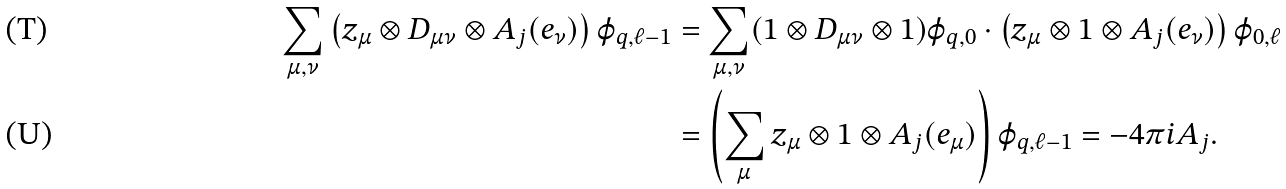<formula> <loc_0><loc_0><loc_500><loc_500>\sum _ { \mu , \nu } \left ( z _ { \mu } \otimes D _ { \mu \nu } \otimes A _ { j } ( e _ { \nu } ) \right ) \varphi _ { q , \ell - 1 } & = \sum _ { \mu , \nu } ( 1 \otimes D _ { \mu \nu } \otimes 1 ) \varphi _ { q , 0 } \cdot \left ( z _ { \mu } \otimes 1 \otimes A _ { j } ( e _ { \nu } ) \right ) \varphi _ { 0 , \ell } \\ & = \left ( \sum _ { \mu } z _ { \mu } \otimes 1 \otimes A _ { j } ( e _ { \mu } ) \right ) \varphi _ { q , \ell - 1 } = - 4 \pi i A _ { j } .</formula> 